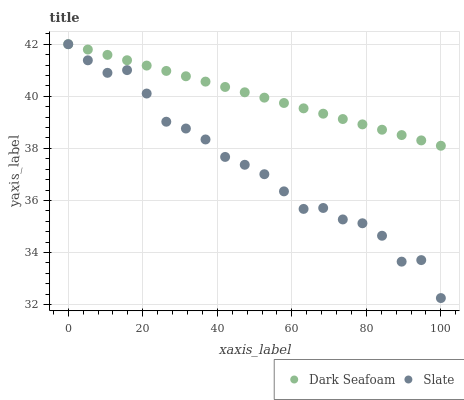Does Slate have the minimum area under the curve?
Answer yes or no. Yes. Does Dark Seafoam have the maximum area under the curve?
Answer yes or no. Yes. Does Slate have the maximum area under the curve?
Answer yes or no. No. Is Dark Seafoam the smoothest?
Answer yes or no. Yes. Is Slate the roughest?
Answer yes or no. Yes. Is Slate the smoothest?
Answer yes or no. No. Does Slate have the lowest value?
Answer yes or no. Yes. Does Slate have the highest value?
Answer yes or no. Yes. Does Slate intersect Dark Seafoam?
Answer yes or no. Yes. Is Slate less than Dark Seafoam?
Answer yes or no. No. Is Slate greater than Dark Seafoam?
Answer yes or no. No. 